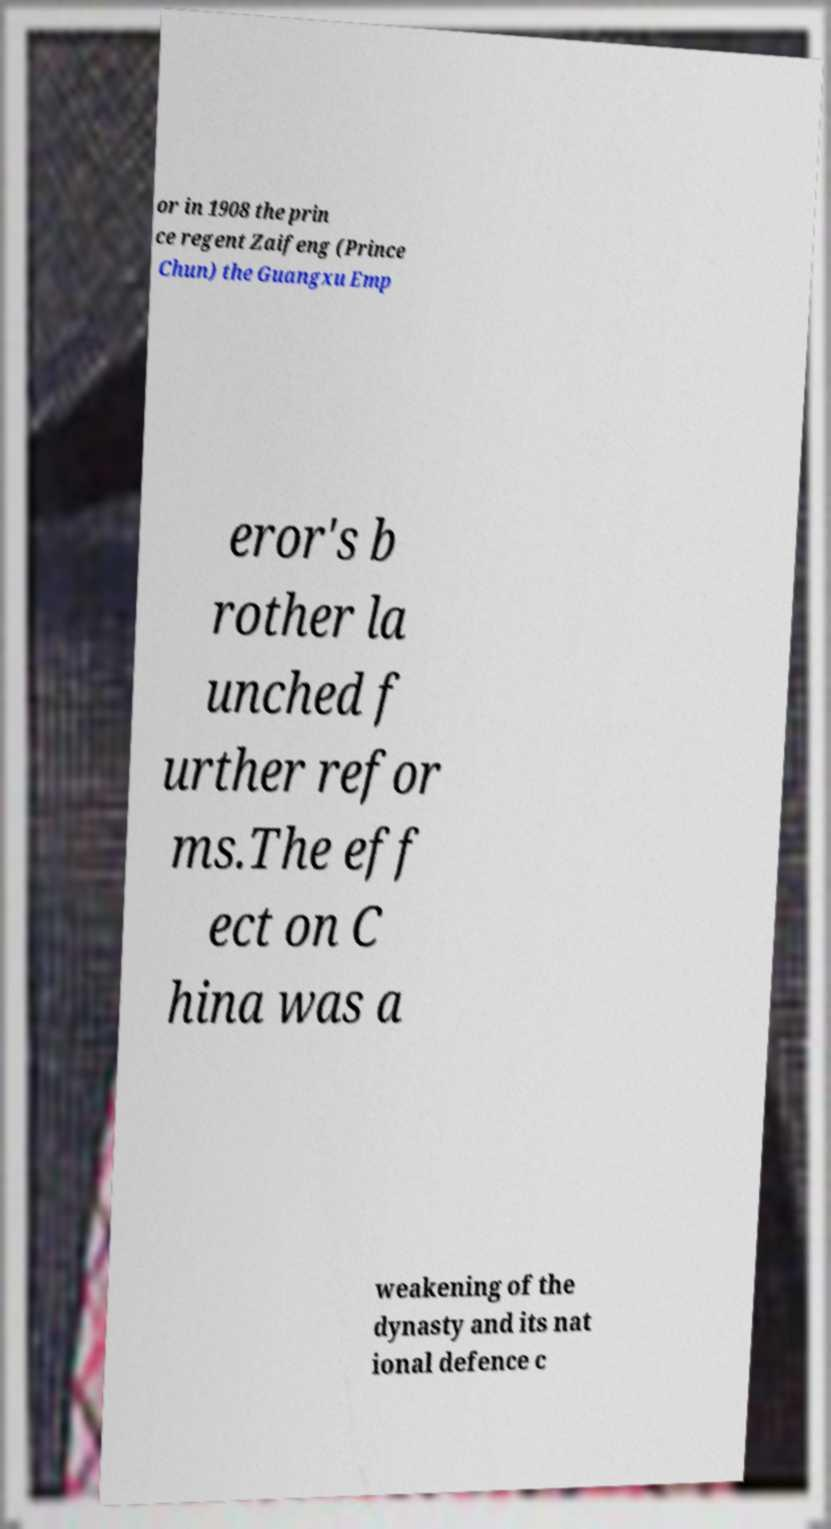Could you assist in decoding the text presented in this image and type it out clearly? or in 1908 the prin ce regent Zaifeng (Prince Chun) the Guangxu Emp eror's b rother la unched f urther refor ms.The eff ect on C hina was a weakening of the dynasty and its nat ional defence c 